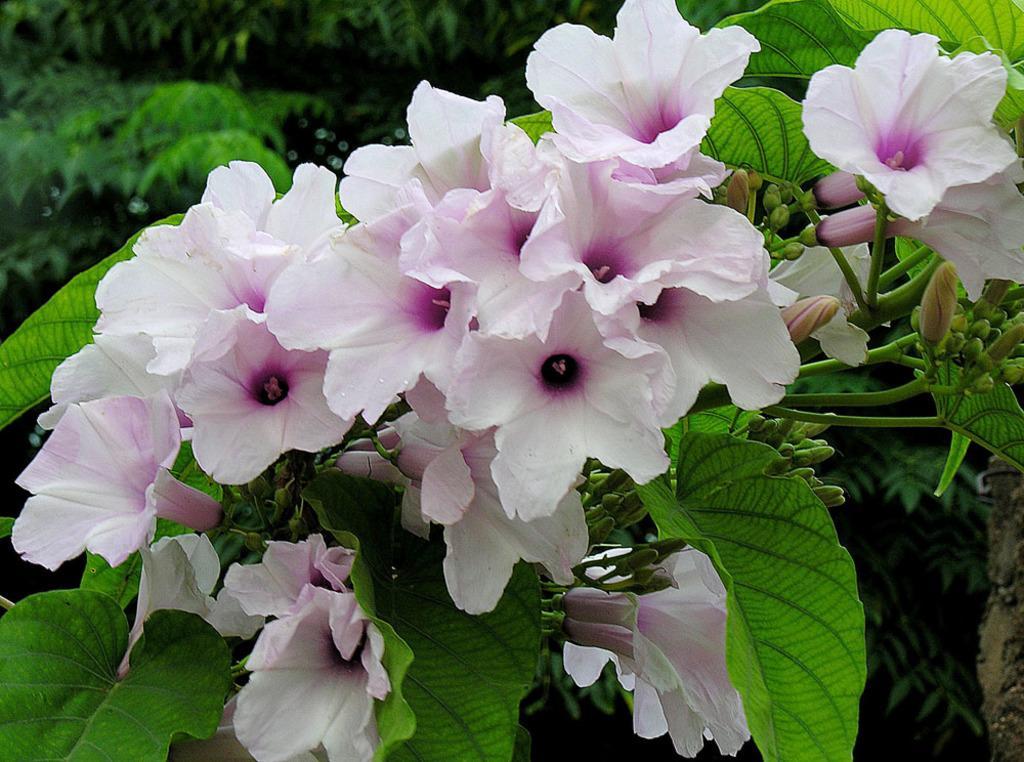In one or two sentences, can you explain what this image depicts? In this image, we can see flowers, leaves, stems and flower buds. In the background, we can see plants. 